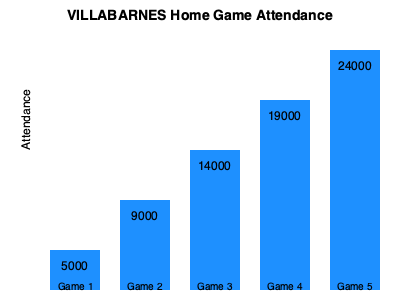As a die-hard VILLABARNES fan, you've been tracking attendance at home games. Using the bar graph showing attendance for the last 5 home games, calculate the average attendance. How many more fans would need to attend each game to reach an average of 15,000 per game? Let's approach this step-by-step:

1. First, we need to calculate the total attendance for all 5 games:
   Game 1: 5,000
   Game 2: 9,000
   Game 3: 14,000
   Game 4: 19,000
   Game 5: 24,000
   Total = $5000 + 9000 + 14000 + 19000 + 24000 = 71000$

2. Now, let's calculate the current average attendance:
   Average = Total Attendance ÷ Number of Games
   $\text{Average} = \frac{71000}{5} = 14200$ fans per game

3. To find out how many more fans are needed to reach an average of 15,000, we need to:
   a) Calculate the total attendance needed for 5 games with an average of 15,000:
      $15000 \times 5 = 75000$ total fans needed

   b) Subtract the current total attendance from this number:
      $75000 - 71000 = 4000$ additional fans needed in total

   c) Divide this by the number of games to get the increase needed per game:
      $\frac{4000}{5} = 800$ additional fans per game

Therefore, 800 more fans would need to attend each game to reach an average of 15,000 per game.
Answer: 800 fans 